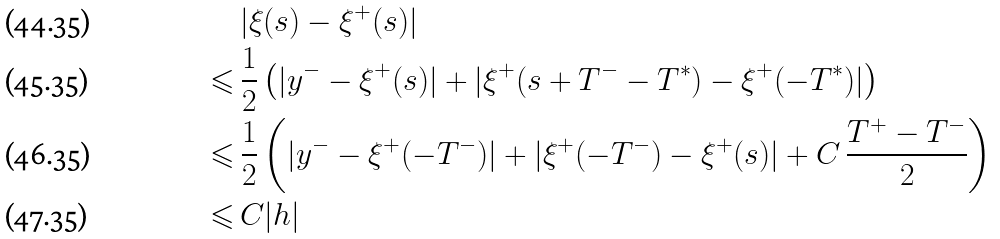Convert formula to latex. <formula><loc_0><loc_0><loc_500><loc_500>& \, | \xi ( s ) - \xi ^ { + } ( s ) | \\ \leqslant & \, \frac { 1 } { 2 } \left ( | y ^ { - } - \xi ^ { + } ( s ) | + | \xi ^ { + } ( s + T ^ { - } - T ^ { * } ) - \xi ^ { + } ( - T ^ { * } ) | \right ) \\ \leqslant & \, \frac { 1 } { 2 } \left ( | y ^ { - } - \xi ^ { + } ( - T ^ { - } ) | + | \xi ^ { + } ( - T ^ { - } ) - \xi ^ { + } ( s ) | + C \, \frac { T ^ { + } - T ^ { - } } { 2 } \right ) \\ \leqslant & \, C | h |</formula> 